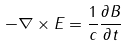<formula> <loc_0><loc_0><loc_500><loc_500>- \nabla \times E = \frac { 1 } { c } \frac { \partial B } { \partial t }</formula> 